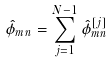<formula> <loc_0><loc_0><loc_500><loc_500>\hat { \phi } _ { m n } = \sum _ { j = 1 } ^ { N - 1 } \hat { \phi } _ { m n } ^ { [ j ] }</formula> 